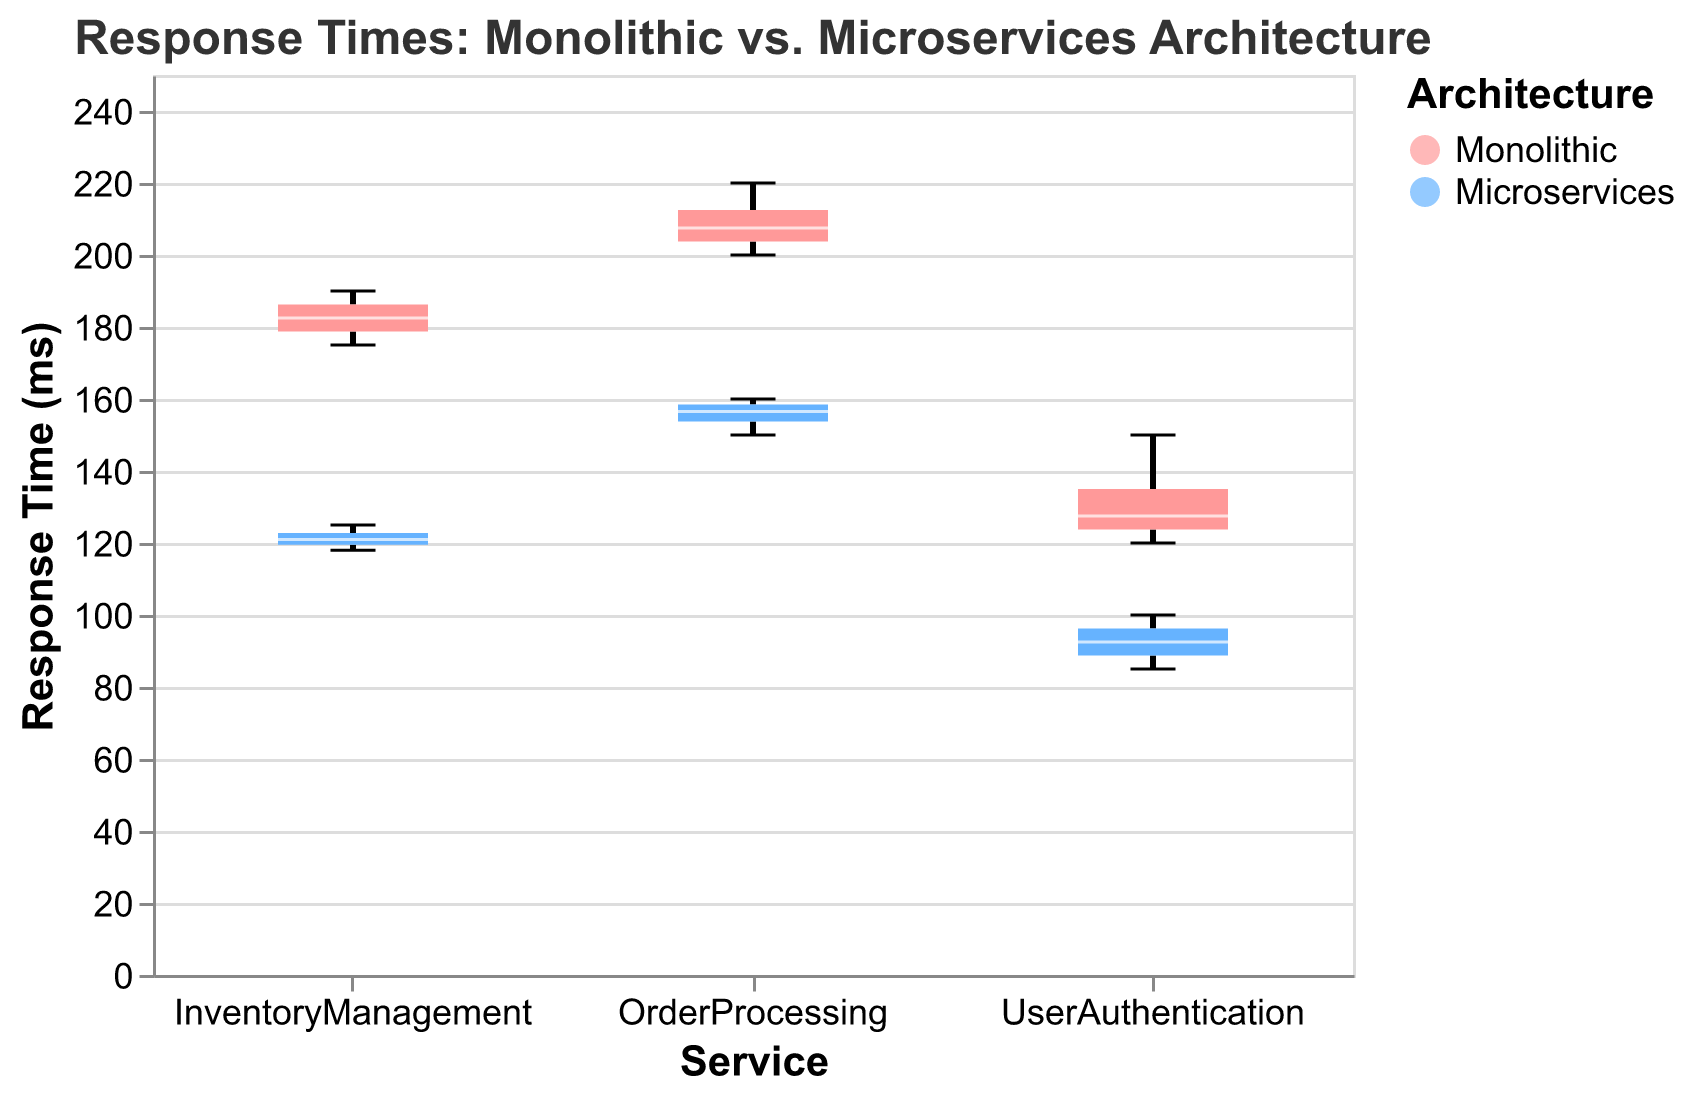What is the title of the figure? The title of the figure is usually found at the top and provides a summary of what the chart is about. Looking at the provided visualization, the title is "Response Times: Monolithic vs. Microservices Architecture."
Answer: Response Times: Monolithic vs. Microservices Architecture What services are compared in the figure? The services compared are usually labeled on the x-axis. In this case, the x-axis displays three services: UserAuthentication, OrderProcessing, and InventoryManagement.
Answer: UserAuthentication, OrderProcessing, InventoryManagement Which architecture generally has lower response times in all services? By comparing the median response time for Monolithic and Microservices architectures across all services, it is noticeable that Microservices generally have lower response times for UserAuthentication, OrderProcessing, and InventoryManagement.
Answer: Microservices What is the median response time for UserAuthentication in a microservices architecture? The median response time is typically marked by a central line within each box on a boxplot. For the UserAuthentication service under Microservices, the median value appears to be 95 ms.
Answer: 95 ms Which service shows the greatest difference in median response times between Monolithic and Microservices architectures? To determine this, we must compare the median response times for Monolithic and Microservices architectures in each service. The UserAuthentication service shows a difference of 35 milliseconds (130 ms Monolithic - 95 ms Microservices), OrderProcessing shows 50 milliseconds (210 ms Monolithic - 160 ms Microservices), and InventoryManagement shows 60 milliseconds (182.5 ms Monolithic - 122 ms Microservices). Thus, InventoryManagement has the greatest difference of 60 milliseconds.
Answer: InventoryManagement How do the response time ranges compare between Monolithic and Microservices for OrderProcessing? The range is the difference between the maximum and minimum response times. For OrderProcessing in Monolithic, the range is between 200 ms and 220 ms (20 ms range). For Microservices, the range is between 150 ms and 160 ms (10 ms range). This indicates that Monolithic has a broader range in response times than Microservices.
Answer: Monolithic has a broader range Are there any outliers in the response times for the services? Outliers in boxplots are typically shown as individual points outside the whiskers. There are no visible outliers for any of the services in either Monolithic or Microservices architectures on this figure.
Answer: No outliers What are the quartiles displayed for the InventoryManagement service under the Microservices architecture? For InventoryManagement under Microservices, the boxplot indicates the 25th percentile (Q1), median (Q2), and 75th percentile (Q3). Based on the plot, Q1 appears near 118 ms, Q2 at ~122 ms, and Q3 at ~125 ms.
Answer: Q1: 118 ms, Q2: 122 ms, Q3: 125 ms Which architecture has a larger interquartile range (IQR) for the UserAuthentication service? The IQR is determined by subtracting the 25th percentile (Q1) from the 75th percentile (Q3). For Monolithic, it's 150 - 120 = 30 ms. For Microservices, it's 100 - 90 = 10 ms. Therefore, UserAuthentication under Monolithic architecture has a larger IQR.
Answer: Monolithic What is the maximum response time recorded for OrderProcessing under the Monolithic architecture? The maximum response time in a boxplot is indicated by the top whisker. For OrderProcessing under Monolithic architecture, this whisker extends to 220 ms.
Answer: 220 ms 